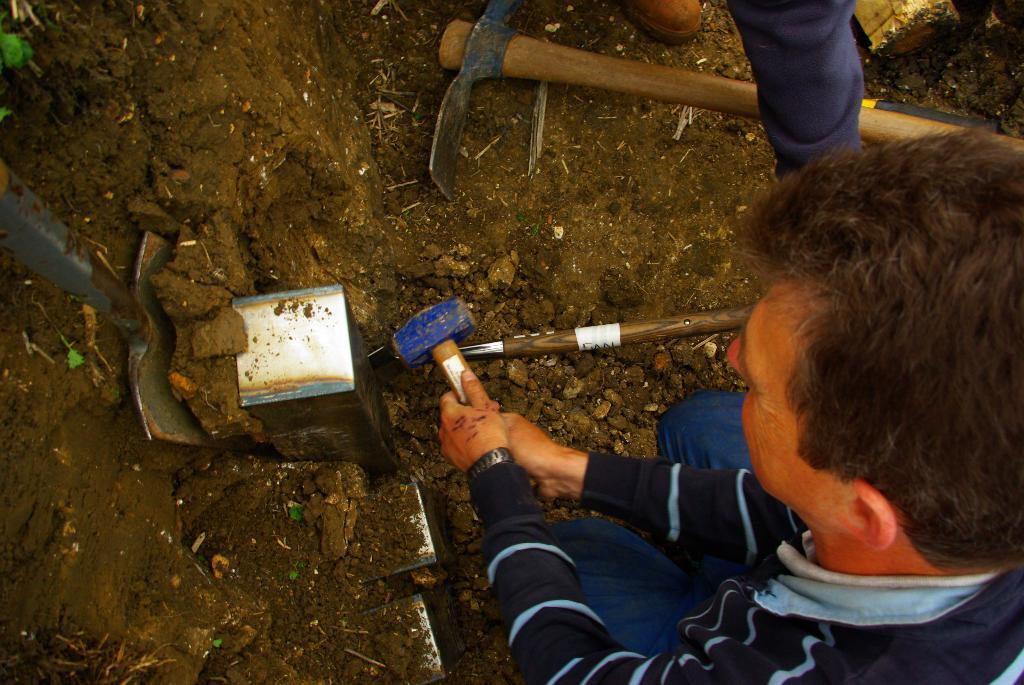Who is present in the image? There is a person in the image. What is the person holding in their hands? The person is holding a hammer. Where is the hammer located in relation to the person? The hammer is in the person's hands. What else can be seen on the ground in the image? There are tools on the ground in the image. What type of chicken is being played in the background of the image? There is no chicken or music present in the image; it features a person holding a hammer and tools on the ground. 